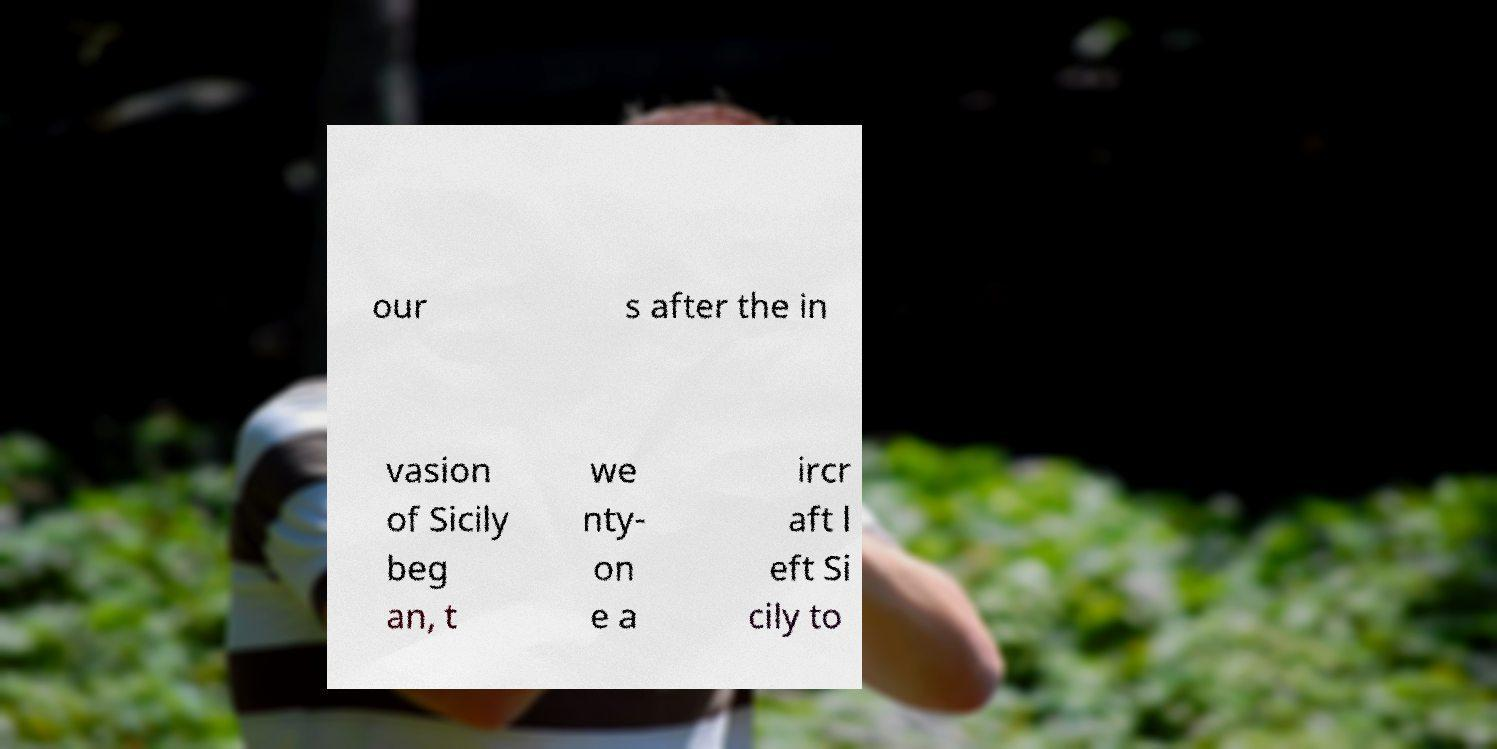For documentation purposes, I need the text within this image transcribed. Could you provide that? our s after the in vasion of Sicily beg an, t we nty- on e a ircr aft l eft Si cily to 